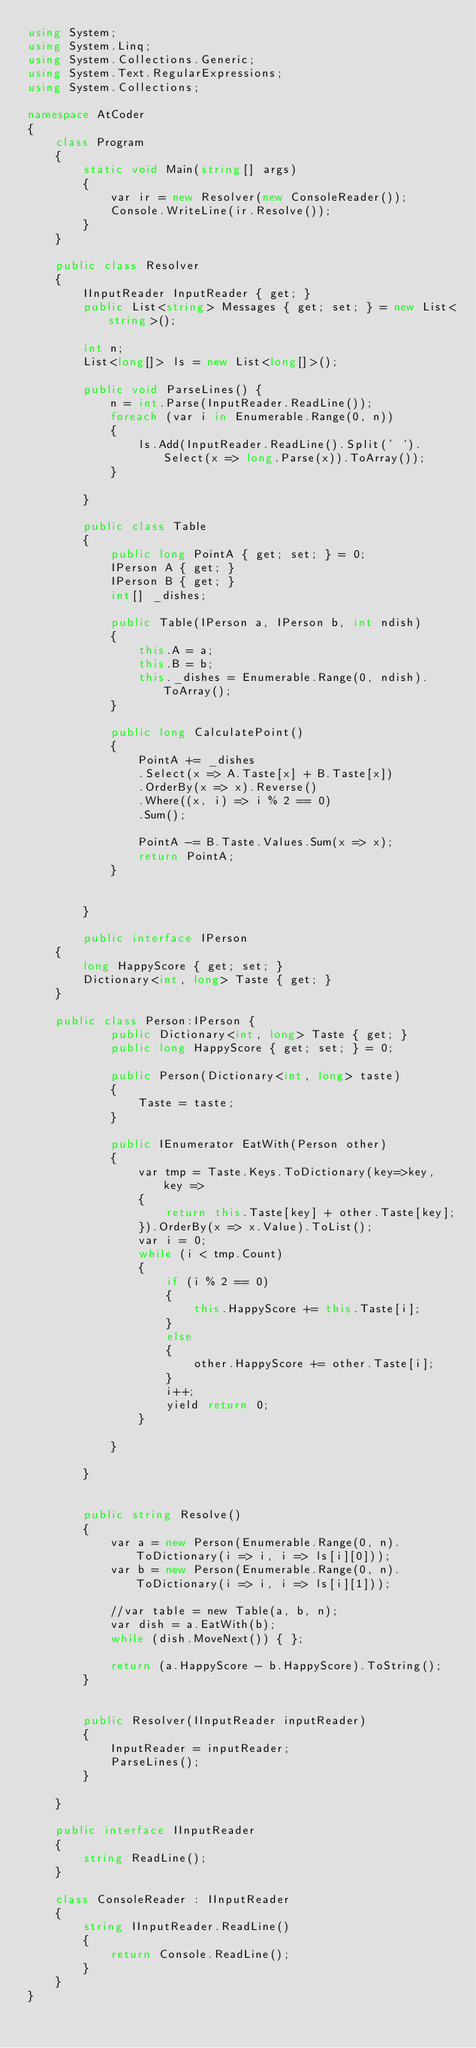Convert code to text. <code><loc_0><loc_0><loc_500><loc_500><_C#_>using System;
using System.Linq;
using System.Collections.Generic;
using System.Text.RegularExpressions;
using System.Collections;

namespace AtCoder
{
    class Program
    {
        static void Main(string[] args)
        {
            var ir = new Resolver(new ConsoleReader());
            Console.WriteLine(ir.Resolve());
        }
    }

    public class Resolver
    {
        IInputReader InputReader { get; }
        public List<string> Messages { get; set; } = new List<string>();

        int n;
        List<long[]> ls = new List<long[]>();

        public void ParseLines() {
            n = int.Parse(InputReader.ReadLine());
            foreach (var i in Enumerable.Range(0, n))
            {
                ls.Add(InputReader.ReadLine().Split(' ').Select(x => long.Parse(x)).ToArray());
            }

        }

        public class Table
        {
            public long PointA { get; set; } = 0;
            IPerson A { get; }
            IPerson B { get; }
            int[] _dishes;

            public Table(IPerson a, IPerson b, int ndish)
            {
                this.A = a;
                this.B = b;
                this._dishes = Enumerable.Range(0, ndish).ToArray();
            }

            public long CalculatePoint()
            {
                PointA += _dishes
                .Select(x => A.Taste[x] + B.Taste[x])
                .OrderBy(x => x).Reverse()
                .Where((x, i) => i % 2 == 0)
                .Sum();

                PointA -= B.Taste.Values.Sum(x => x);
                return PointA;
            }


        }

        public interface IPerson
    {
        long HappyScore { get; set; }
        Dictionary<int, long> Taste { get; }
    }

    public class Person:IPerson {
            public Dictionary<int, long> Taste { get; }
            public long HappyScore { get; set; } = 0;

            public Person(Dictionary<int, long> taste)
            {
                Taste = taste;
            }

            public IEnumerator EatWith(Person other)
            {
                var tmp = Taste.Keys.ToDictionary(key=>key, key =>
                {
                    return this.Taste[key] + other.Taste[key];
                }).OrderBy(x => x.Value).ToList();
                var i = 0;
                while (i < tmp.Count)
                {
                    if (i % 2 == 0)
                    {
                        this.HappyScore += this.Taste[i];
                    }
                    else
                    {
                        other.HappyScore += other.Taste[i];
                    }
                    i++;
                    yield return 0;
                }

            }

        }


        public string Resolve()
        {
            var a = new Person(Enumerable.Range(0, n).ToDictionary(i => i, i => ls[i][0]));
            var b = new Person(Enumerable.Range(0, n).ToDictionary(i => i, i => ls[i][1]));

            //var table = new Table(a, b, n);
            var dish = a.EatWith(b);
            while (dish.MoveNext()) { };

            return (a.HappyScore - b.HappyScore).ToString();
        }


        public Resolver(IInputReader inputReader)
        {
            InputReader = inputReader;
            ParseLines();
        }

    }

    public interface IInputReader
    {
        string ReadLine();
    }

    class ConsoleReader : IInputReader
    {
        string IInputReader.ReadLine()
        {
            return Console.ReadLine();
        }
    }
}
</code> 